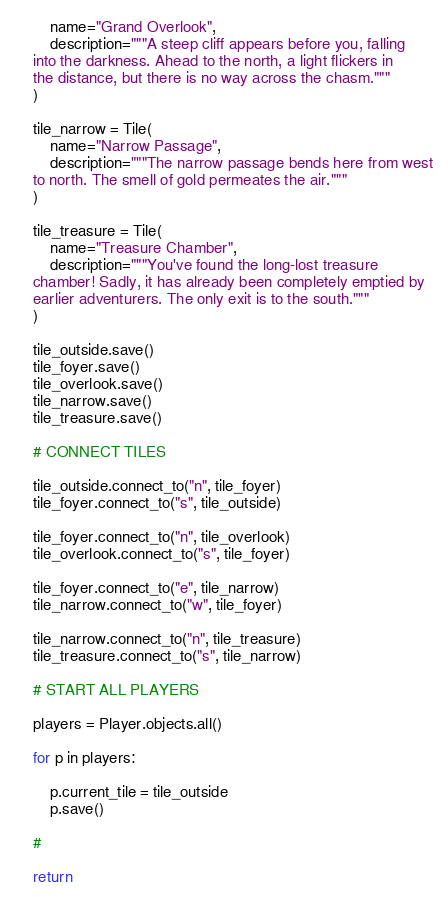Convert code to text. <code><loc_0><loc_0><loc_500><loc_500><_Python_>        name="Grand Overlook",
        description="""A steep cliff appears before you, falling
    into the darkness. Ahead to the north, a light flickers in
    the distance, but there is no way across the chasm."""
    )

    tile_narrow = Tile(
        name="Narrow Passage",
        description="""The narrow passage bends here from west
    to north. The smell of gold permeates the air."""
    )

    tile_treasure = Tile(
        name="Treasure Chamber",
        description="""You've found the long-lost treasure
    chamber! Sadly, it has already been completely emptied by
    earlier adventurers. The only exit is to the south."""
    )

    tile_outside.save()
    tile_foyer.save()
    tile_overlook.save()
    tile_narrow.save()
    tile_treasure.save()

    # CONNECT TILES

    tile_outside.connect_to("n", tile_foyer)
    tile_foyer.connect_to("s", tile_outside)

    tile_foyer.connect_to("n", tile_overlook)
    tile_overlook.connect_to("s", tile_foyer)

    tile_foyer.connect_to("e", tile_narrow)
    tile_narrow.connect_to("w", tile_foyer)

    tile_narrow.connect_to("n", tile_treasure)
    tile_treasure.connect_to("s", tile_narrow)

    # START ALL PLAYERS

    players = Player.objects.all()

    for p in players:

        p.current_tile = tile_outside
        p.save()

    #

    return
</code> 